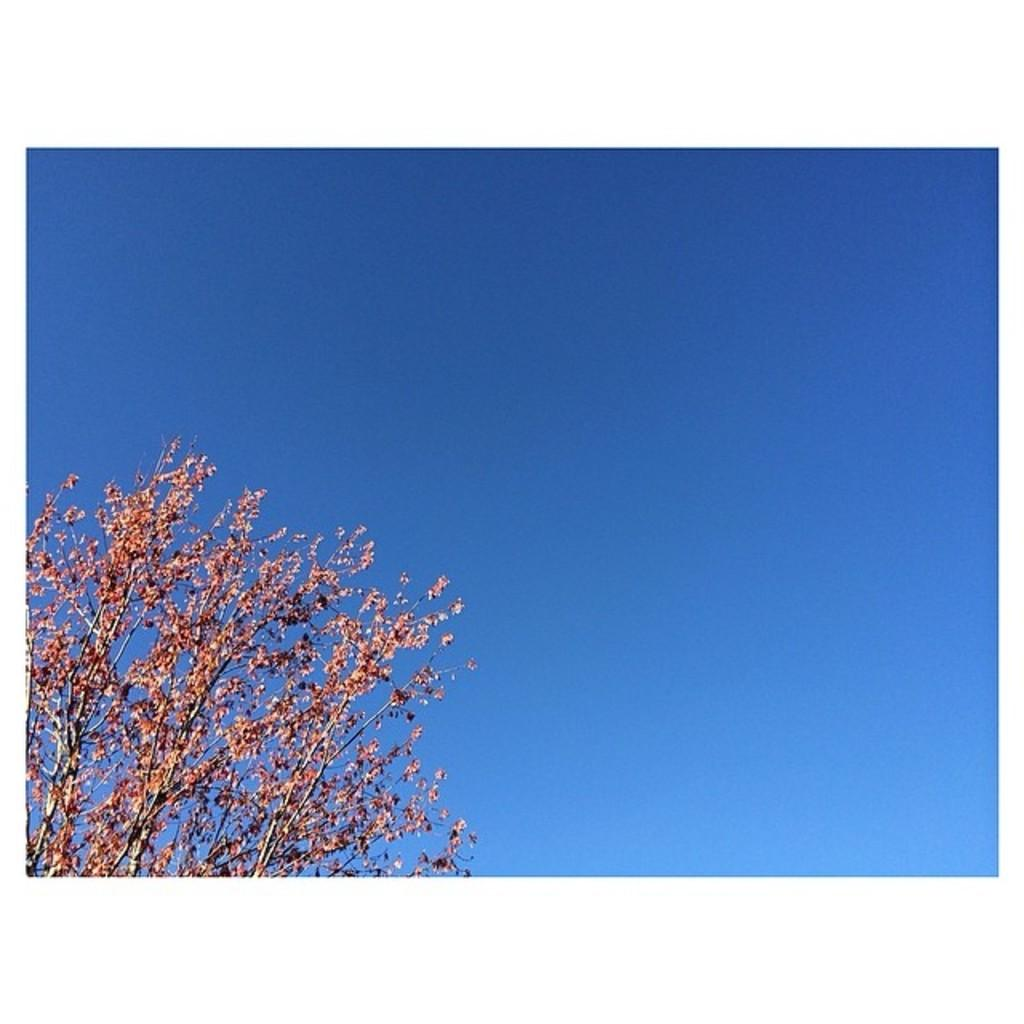What type of vegetation can be seen in the image? There are branches of a tree in the image. What else is visible in the image besides the tree branches? The sky is visible in the image. How would you describe the sky in the image? The sky appears to be cloudy. What type of potato is being used to hold up the jeans in the image? There is no potato or jeans present in the image; it only features tree branches and a cloudy sky. 